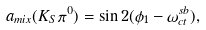Convert formula to latex. <formula><loc_0><loc_0><loc_500><loc_500>a _ { m i x } ( K _ { S } \pi ^ { 0 } ) = \sin 2 ( \phi _ { 1 } - \omega _ { c t } ^ { s b } ) ,</formula> 